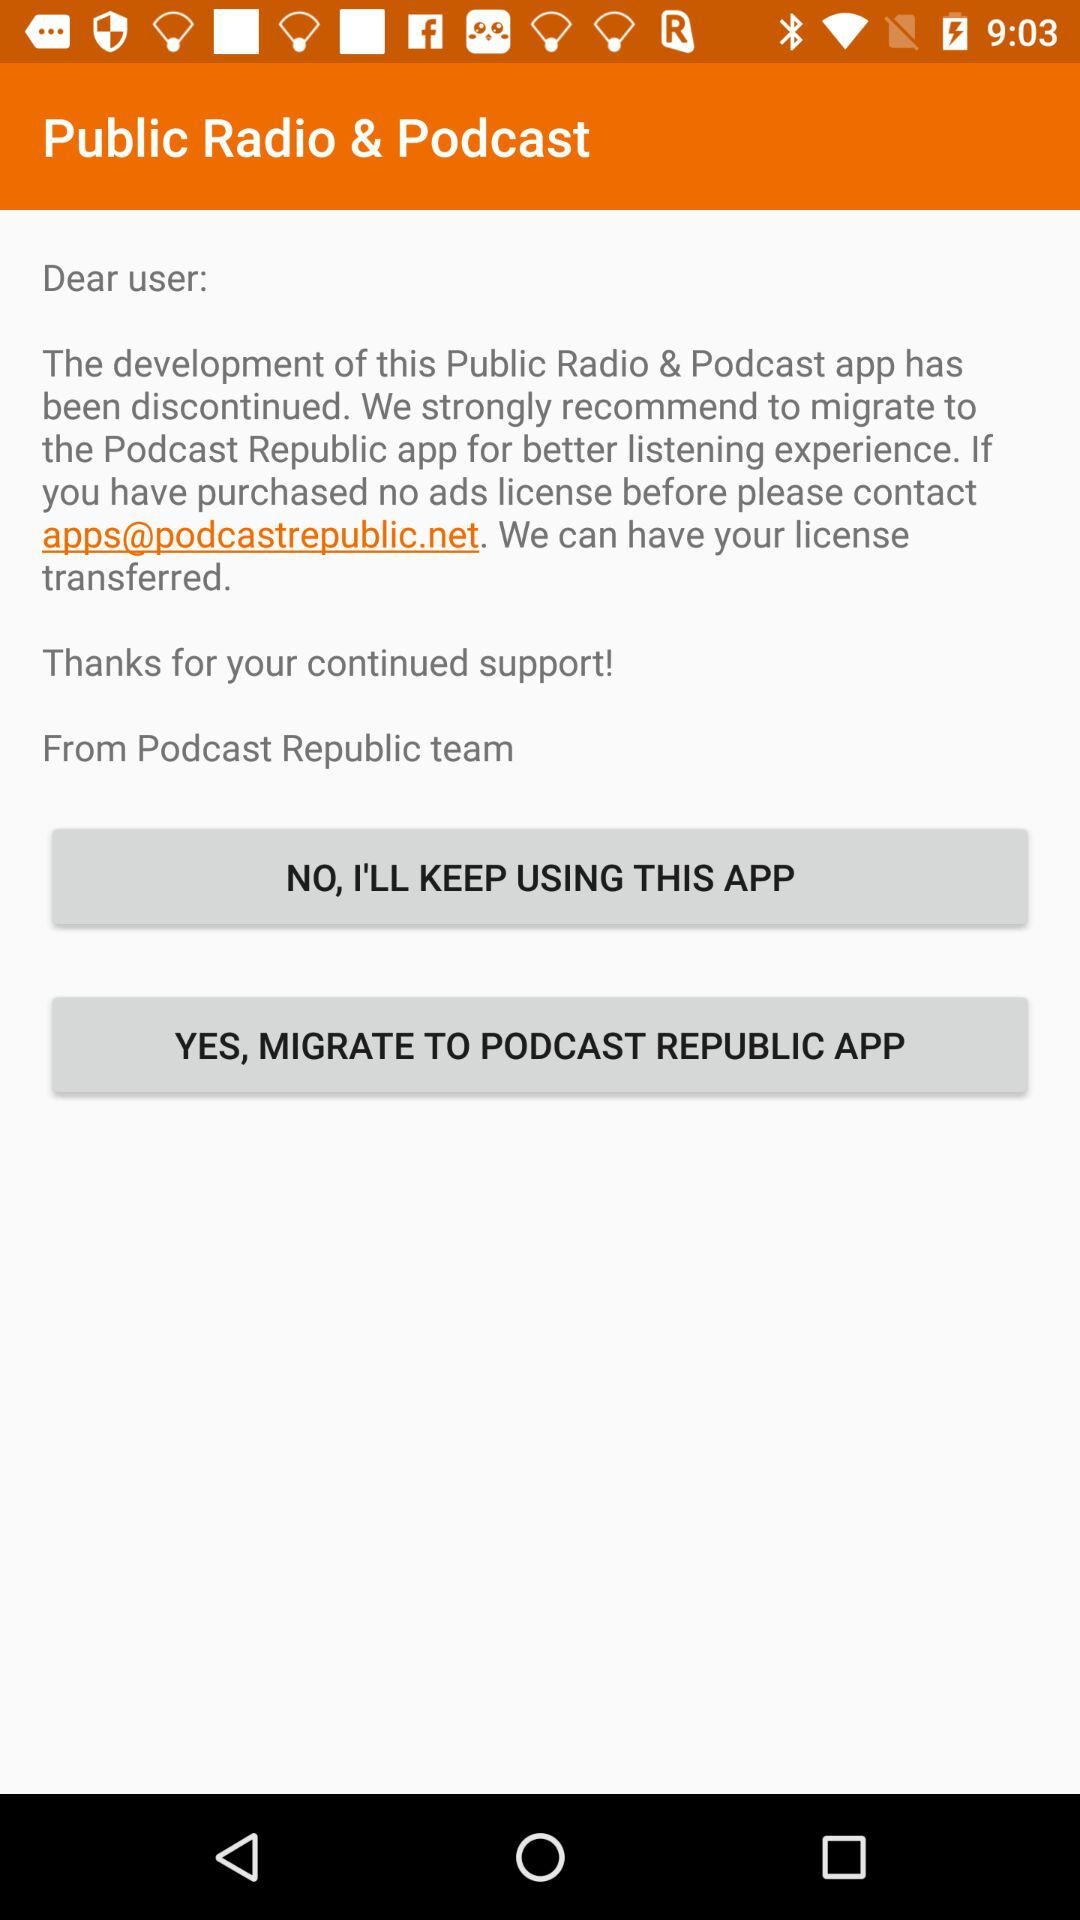What is the name of the user?
When the provided information is insufficient, respond with <no answer>. <no answer> 